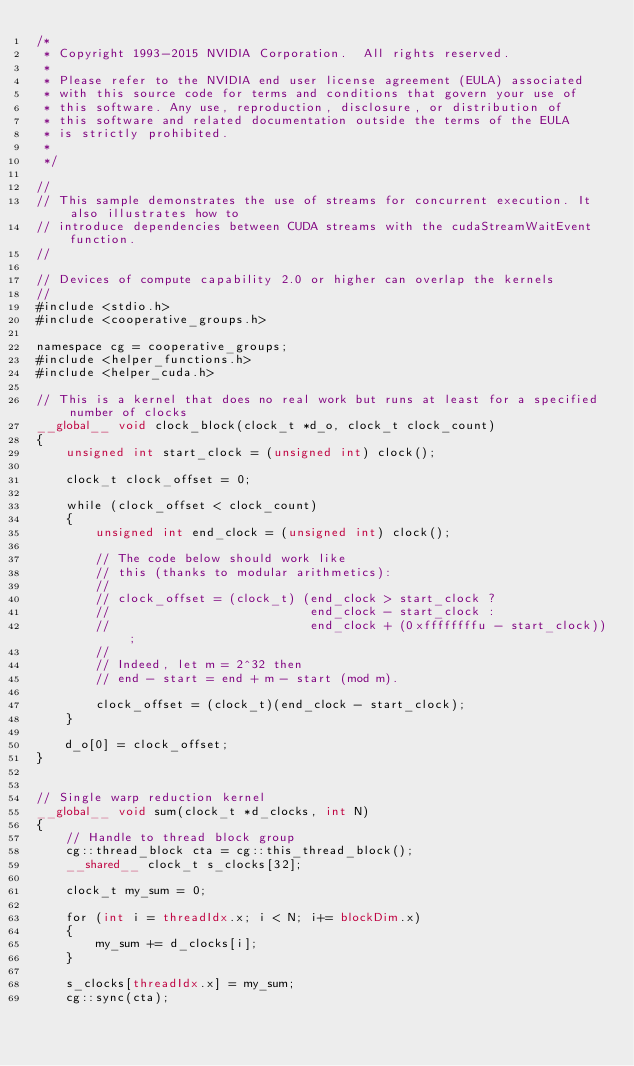<code> <loc_0><loc_0><loc_500><loc_500><_Cuda_>/*
 * Copyright 1993-2015 NVIDIA Corporation.  All rights reserved.
 *
 * Please refer to the NVIDIA end user license agreement (EULA) associated
 * with this source code for terms and conditions that govern your use of
 * this software. Any use, reproduction, disclosure, or distribution of
 * this software and related documentation outside the terms of the EULA
 * is strictly prohibited.
 *
 */

//
// This sample demonstrates the use of streams for concurrent execution. It also illustrates how to
// introduce dependencies between CUDA streams with the cudaStreamWaitEvent function.
//

// Devices of compute capability 2.0 or higher can overlap the kernels
//
#include <stdio.h>
#include <cooperative_groups.h>

namespace cg = cooperative_groups;
#include <helper_functions.h>
#include <helper_cuda.h>

// This is a kernel that does no real work but runs at least for a specified number of clocks
__global__ void clock_block(clock_t *d_o, clock_t clock_count)
{
    unsigned int start_clock = (unsigned int) clock();

    clock_t clock_offset = 0;

    while (clock_offset < clock_count)
    {
        unsigned int end_clock = (unsigned int) clock();

        // The code below should work like
        // this (thanks to modular arithmetics):
        //
        // clock_offset = (clock_t) (end_clock > start_clock ?
        //                           end_clock - start_clock :
        //                           end_clock + (0xffffffffu - start_clock));
        //
        // Indeed, let m = 2^32 then
        // end - start = end + m - start (mod m).

        clock_offset = (clock_t)(end_clock - start_clock);
    }

    d_o[0] = clock_offset;
}


// Single warp reduction kernel
__global__ void sum(clock_t *d_clocks, int N)
{
    // Handle to thread block group
    cg::thread_block cta = cg::this_thread_block();
    __shared__ clock_t s_clocks[32];

    clock_t my_sum = 0;

    for (int i = threadIdx.x; i < N; i+= blockDim.x)
    {
        my_sum += d_clocks[i];
    }

    s_clocks[threadIdx.x] = my_sum;
    cg::sync(cta);
</code> 